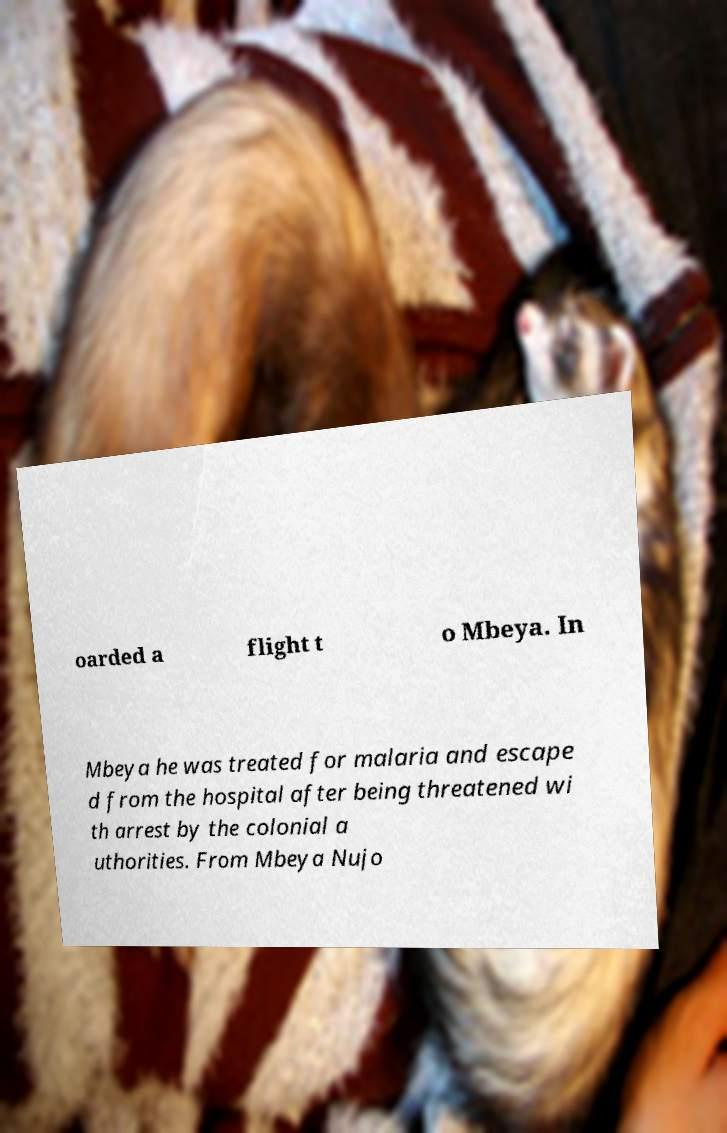Could you assist in decoding the text presented in this image and type it out clearly? oarded a flight t o Mbeya. In Mbeya he was treated for malaria and escape d from the hospital after being threatened wi th arrest by the colonial a uthorities. From Mbeya Nujo 